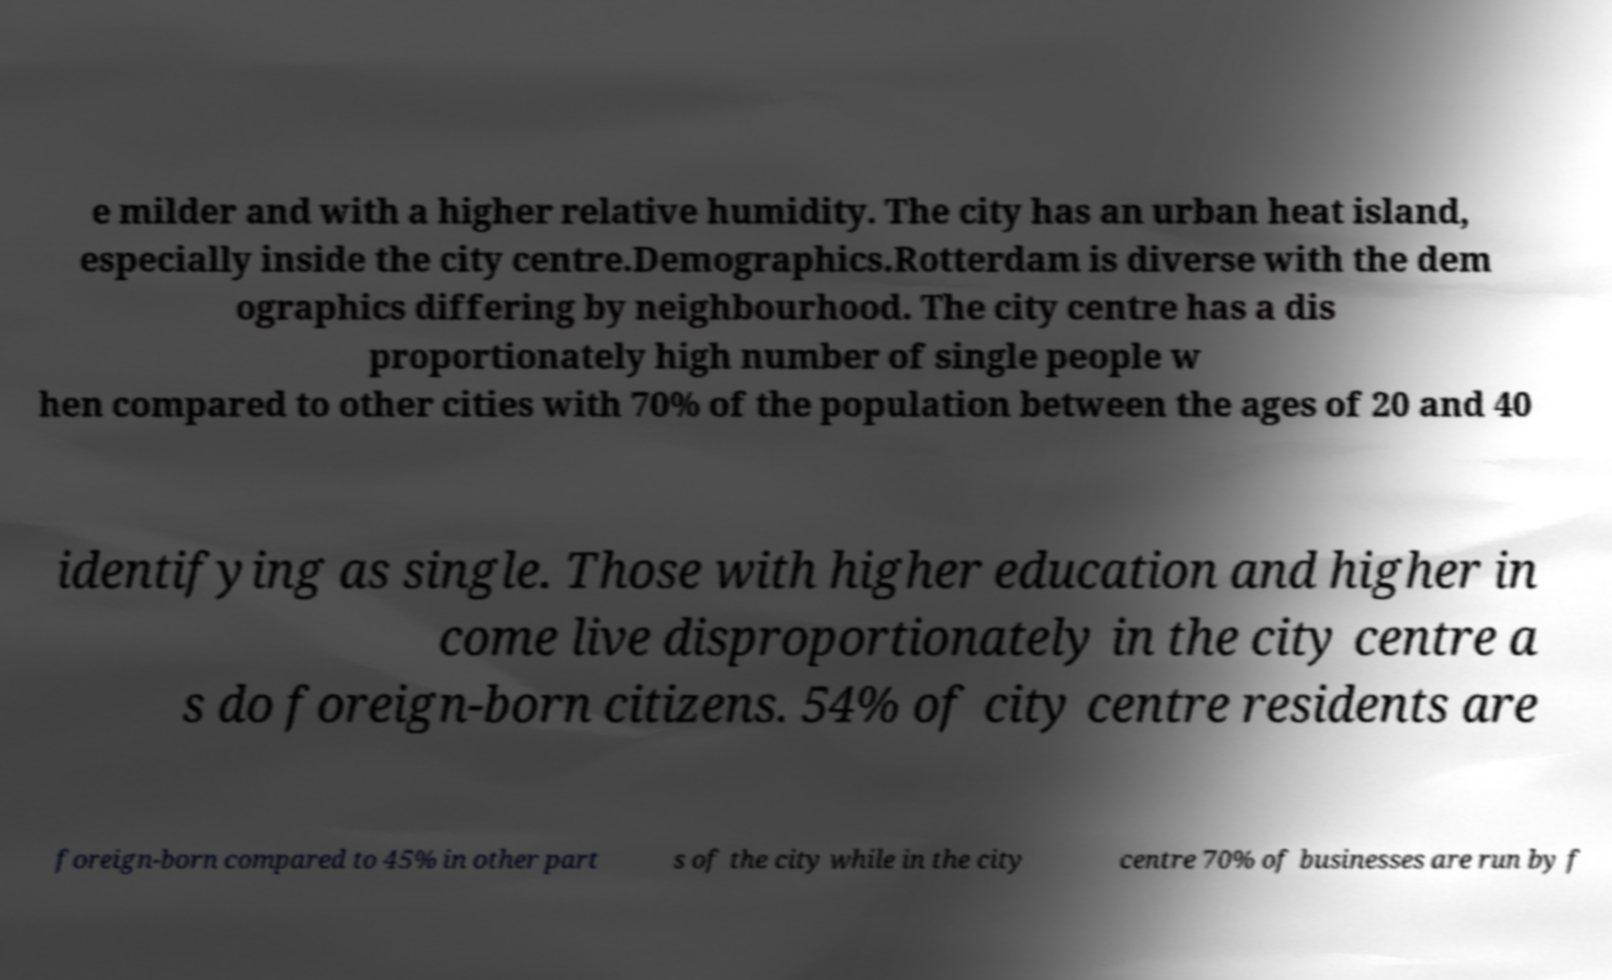I need the written content from this picture converted into text. Can you do that? e milder and with a higher relative humidity. The city has an urban heat island, especially inside the city centre.Demographics.Rotterdam is diverse with the dem ographics differing by neighbourhood. The city centre has a dis proportionately high number of single people w hen compared to other cities with 70% of the population between the ages of 20 and 40 identifying as single. Those with higher education and higher in come live disproportionately in the city centre a s do foreign-born citizens. 54% of city centre residents are foreign-born compared to 45% in other part s of the city while in the city centre 70% of businesses are run by f 